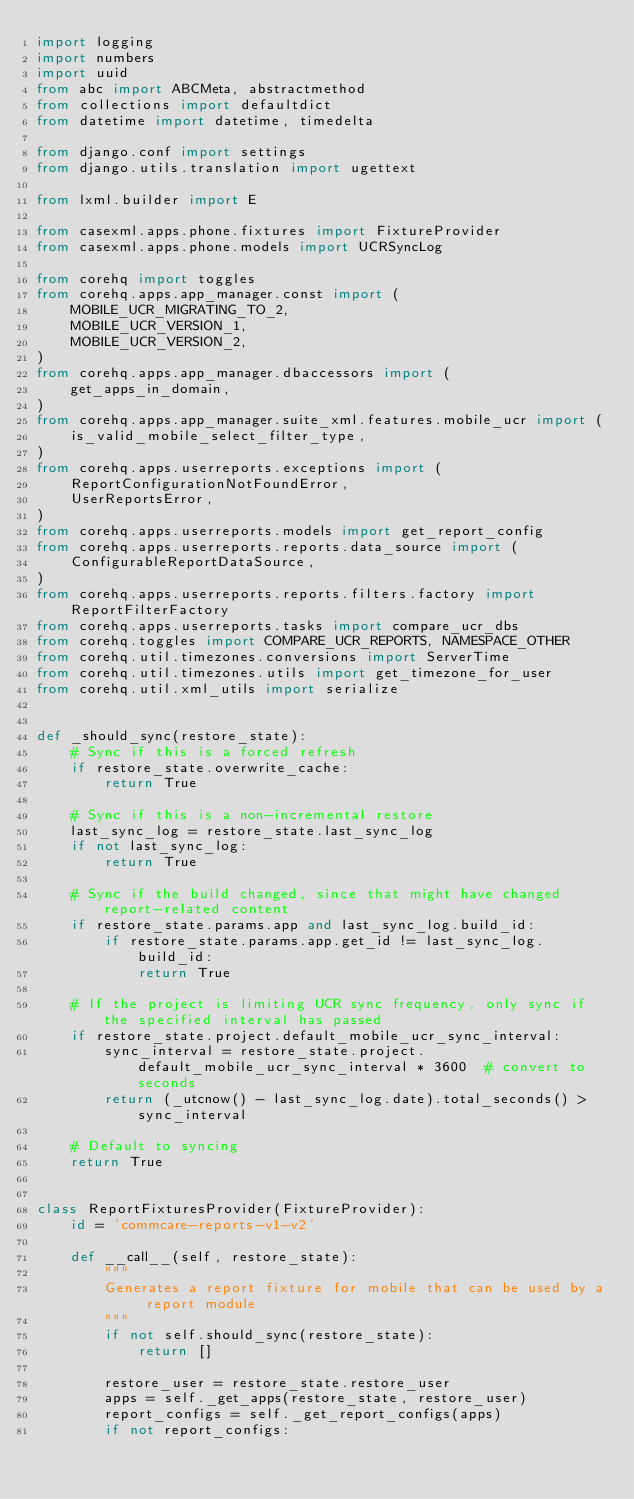<code> <loc_0><loc_0><loc_500><loc_500><_Python_>import logging
import numbers
import uuid
from abc import ABCMeta, abstractmethod
from collections import defaultdict
from datetime import datetime, timedelta

from django.conf import settings
from django.utils.translation import ugettext

from lxml.builder import E

from casexml.apps.phone.fixtures import FixtureProvider
from casexml.apps.phone.models import UCRSyncLog

from corehq import toggles
from corehq.apps.app_manager.const import (
    MOBILE_UCR_MIGRATING_TO_2,
    MOBILE_UCR_VERSION_1,
    MOBILE_UCR_VERSION_2,
)
from corehq.apps.app_manager.dbaccessors import (
    get_apps_in_domain,
)
from corehq.apps.app_manager.suite_xml.features.mobile_ucr import (
    is_valid_mobile_select_filter_type,
)
from corehq.apps.userreports.exceptions import (
    ReportConfigurationNotFoundError,
    UserReportsError,
)
from corehq.apps.userreports.models import get_report_config
from corehq.apps.userreports.reports.data_source import (
    ConfigurableReportDataSource,
)
from corehq.apps.userreports.reports.filters.factory import ReportFilterFactory
from corehq.apps.userreports.tasks import compare_ucr_dbs
from corehq.toggles import COMPARE_UCR_REPORTS, NAMESPACE_OTHER
from corehq.util.timezones.conversions import ServerTime
from corehq.util.timezones.utils import get_timezone_for_user
from corehq.util.xml_utils import serialize


def _should_sync(restore_state):
    # Sync if this is a forced refresh
    if restore_state.overwrite_cache:
        return True

    # Sync if this is a non-incremental restore
    last_sync_log = restore_state.last_sync_log
    if not last_sync_log:
        return True

    # Sync if the build changed, since that might have changed report-related content
    if restore_state.params.app and last_sync_log.build_id:
        if restore_state.params.app.get_id != last_sync_log.build_id:
            return True

    # If the project is limiting UCR sync frequency, only sync if the specified interval has passed
    if restore_state.project.default_mobile_ucr_sync_interval:
        sync_interval = restore_state.project.default_mobile_ucr_sync_interval * 3600  # convert to seconds
        return (_utcnow() - last_sync_log.date).total_seconds() > sync_interval

    # Default to syncing
    return True


class ReportFixturesProvider(FixtureProvider):
    id = 'commcare-reports-v1-v2'

    def __call__(self, restore_state):
        """
        Generates a report fixture for mobile that can be used by a report module
        """
        if not self.should_sync(restore_state):
            return []

        restore_user = restore_state.restore_user
        apps = self._get_apps(restore_state, restore_user)
        report_configs = self._get_report_configs(apps)
        if not report_configs:</code> 